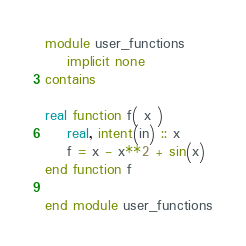<code> <loc_0><loc_0><loc_500><loc_500><_FORTRAN_>module user_functions
    implicit none
contains

real function f( x )
    real, intent(in) :: x
    f = x - x**2 + sin(x)
end function f

end module user_functions</code> 